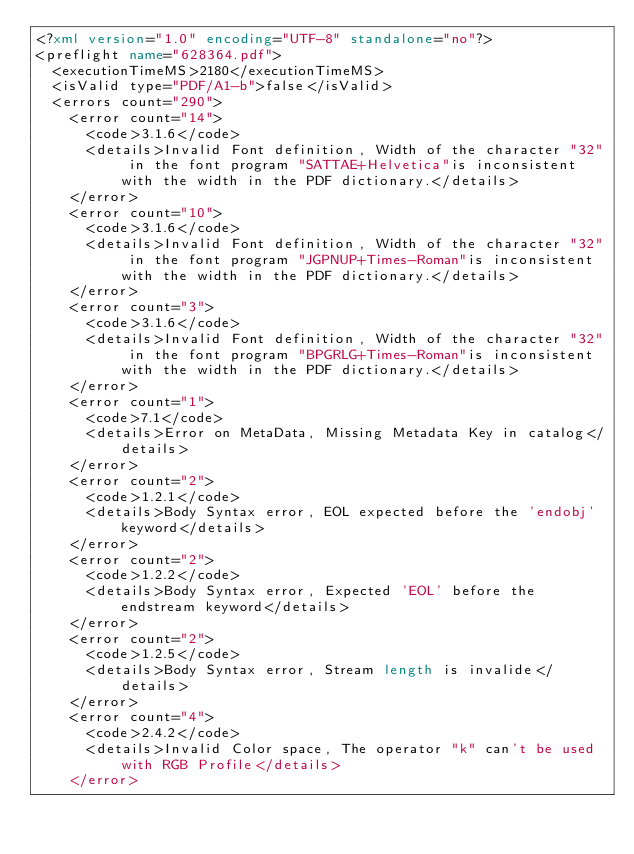Convert code to text. <code><loc_0><loc_0><loc_500><loc_500><_XML_><?xml version="1.0" encoding="UTF-8" standalone="no"?>
<preflight name="628364.pdf">
  <executionTimeMS>2180</executionTimeMS>
  <isValid type="PDF/A1-b">false</isValid>
  <errors count="290">
    <error count="14">
      <code>3.1.6</code>
      <details>Invalid Font definition, Width of the character "32" in the font program "SATTAE+Helvetica"is inconsistent with the width in the PDF dictionary.</details>
    </error>
    <error count="10">
      <code>3.1.6</code>
      <details>Invalid Font definition, Width of the character "32" in the font program "JGPNUP+Times-Roman"is inconsistent with the width in the PDF dictionary.</details>
    </error>
    <error count="3">
      <code>3.1.6</code>
      <details>Invalid Font definition, Width of the character "32" in the font program "BPGRLG+Times-Roman"is inconsistent with the width in the PDF dictionary.</details>
    </error>
    <error count="1">
      <code>7.1</code>
      <details>Error on MetaData, Missing Metadata Key in catalog</details>
    </error>
    <error count="2">
      <code>1.2.1</code>
      <details>Body Syntax error, EOL expected before the 'endobj' keyword</details>
    </error>
    <error count="2">
      <code>1.2.2</code>
      <details>Body Syntax error, Expected 'EOL' before the endstream keyword</details>
    </error>
    <error count="2">
      <code>1.2.5</code>
      <details>Body Syntax error, Stream length is invalide</details>
    </error>
    <error count="4">
      <code>2.4.2</code>
      <details>Invalid Color space, The operator "k" can't be used with RGB Profile</details>
    </error></code> 